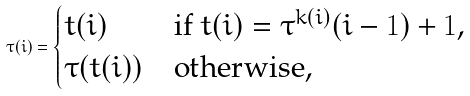<formula> <loc_0><loc_0><loc_500><loc_500>\tau ( i ) = \begin{cases} t ( i ) & \text {if $t(i) = \tau^{k(i)}(i-1)+1$,} \\ \tau ( t ( i ) ) & \text {otherwise,} \end{cases}</formula> 